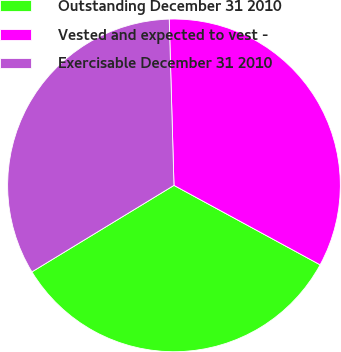Convert chart to OTSL. <chart><loc_0><loc_0><loc_500><loc_500><pie_chart><fcel>Outstanding December 31 2010<fcel>Vested and expected to vest -<fcel>Exercisable December 31 2010<nl><fcel>33.37%<fcel>33.38%<fcel>33.25%<nl></chart> 